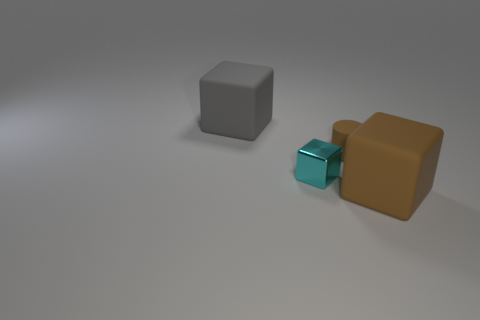Add 1 large brown matte things. How many objects exist? 5 Add 2 big cyan matte cubes. How many big cyan matte cubes exist? 2 Subtract all brown cubes. How many cubes are left? 2 Subtract all large matte blocks. How many blocks are left? 1 Subtract 0 blue spheres. How many objects are left? 4 Subtract all cubes. How many objects are left? 1 Subtract 2 blocks. How many blocks are left? 1 Subtract all red cubes. Subtract all cyan spheres. How many cubes are left? 3 Subtract all purple cylinders. How many gray blocks are left? 1 Subtract all tiny yellow rubber balls. Subtract all big blocks. How many objects are left? 2 